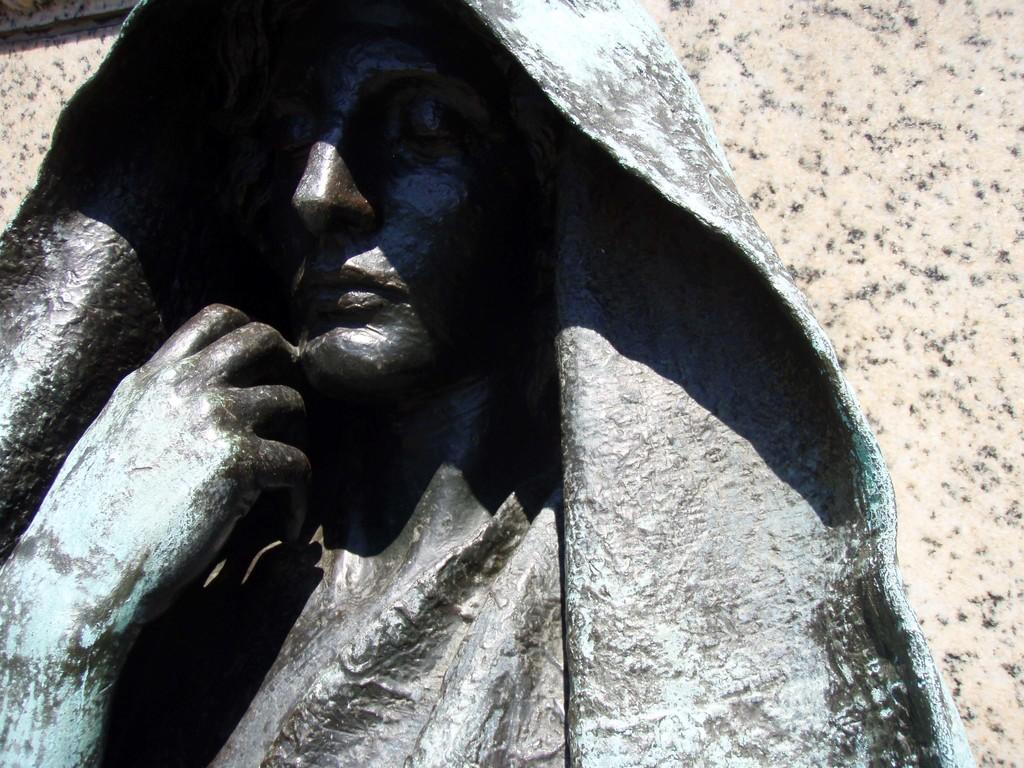What is the main subject in the image? There is a sculpture in the image. What can be seen in the background of the image? There is a wall in the background of the image. How does the yard react to the presence of the visitor in the image? There is no yard, visitor, or reaction present in the image; it only features a sculpture and a wall in the background. 